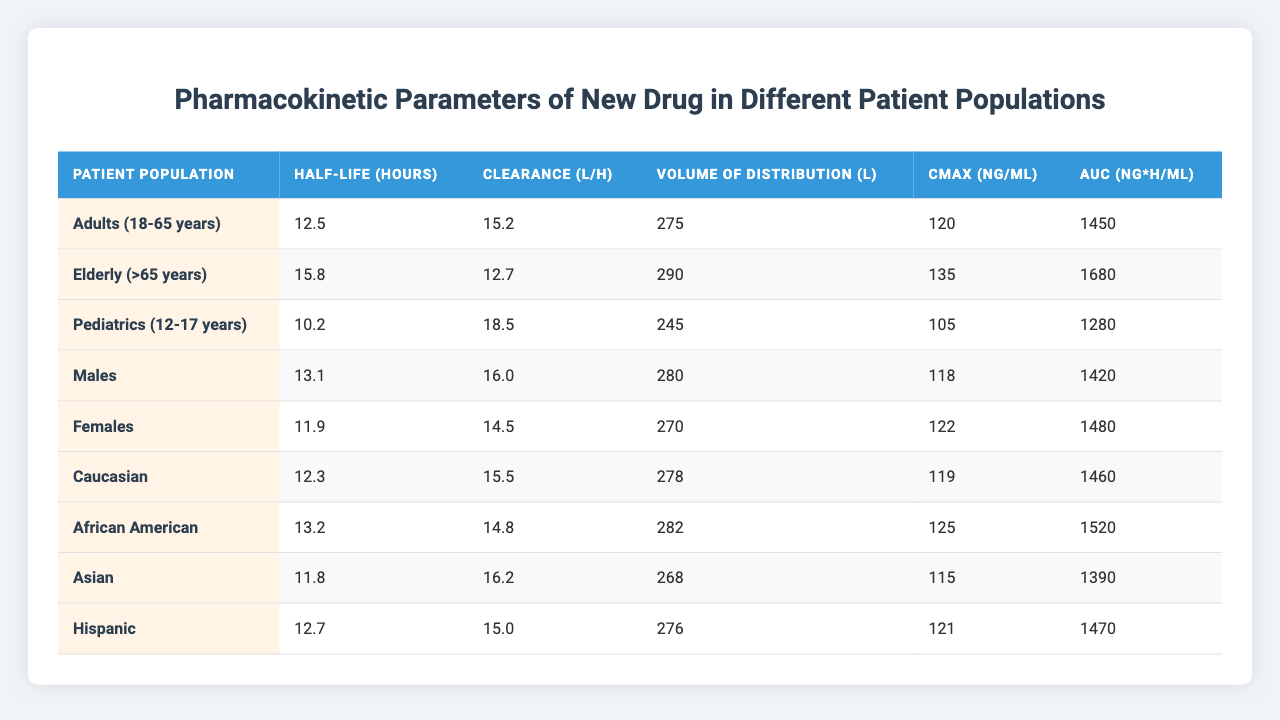What is the half-life of the new drug in elderly patients? The table indicates that the half-life for the elderly population (>65 years) is 15.8 hours as directly stated in the corresponding row.
Answer: 15.8 hours What is the clearance rate for males? According to the table, the clearance rate for males is 16.0 L/h, which is the specific value mentioned in their row.
Answer: 16.0 L/h Which patient population has the lowest volume of distribution? By comparing the volume of distribution values, pediatrics have the lowest value of 245 L, as indicated in their entry in the table.
Answer: Pediatrics (12-17 years) What is the difference in Cmax between females and pediatrics? Cmax for females is 122 ng/mL and for pediatrics, it’s 105 ng/mL. The difference is calculated as 122 - 105 = 17 ng/mL.
Answer: 17 ng/mL What is the AUC for African American patients, is it higher than the AUC for Caucasians? The AUC for African Americans is 1520 ng*h/mL, while Caucasians have an AUC of 1460 ng*h/mL. Since 1520 > 1460, the AUC for African Americans is higher.
Answer: Yes What is the average Cmax across all patient populations listed in the table? To find the average Cmax, sum the Cmax values (120 + 135 + 105 + 118 + 122 + 119 + 125 + 115 + 121) = 1,260. There are 9 populations, so the average is 1,260 / 9 ≈ 140.
Answer: 140 ng/mL Which patient population exhibits the highest clearance rate? The table shows that the pediatrics have the highest clearance rate of 18.5 L/h compared to other groups. This is evident by looking at the clearance values.
Answer: Pediatrics (12-17 years) How does the half-life of the drug differ between the elderly and adults? The half-life for elderly patients is 15.8 hours while for adults it is 12.5 hours. The difference is 15.8 - 12.5 = 3.3 hours, indicating the elderly have a longer half-life.
Answer: 3.3 hours Do males have a higher or lower volume of distribution compared to Hispanic patients? The volume of distribution for males is 280 L, while for Hispanic patients, it is 276 L. Since 280 > 276, males have a higher volume of distribution.
Answer: Higher What is the trend in AUC values across different age groups? Comparing the AUC values: Adults (1450), Elderly (1680), and Pediatrics (1280). The trend shows that AUC increases in the elderly compared to adults and pediatrics. Therefore, the AUC is highest in the elderly.
Answer: Increases with age Is the Cmax for Asians greater than for Hispanic patients? The Cmax for Asians is 115 ng/mL, while for Hispanics it’s 121 ng/mL. Since 115 < 121, the Cmax for Asians is not greater than for Hispanics.
Answer: No 